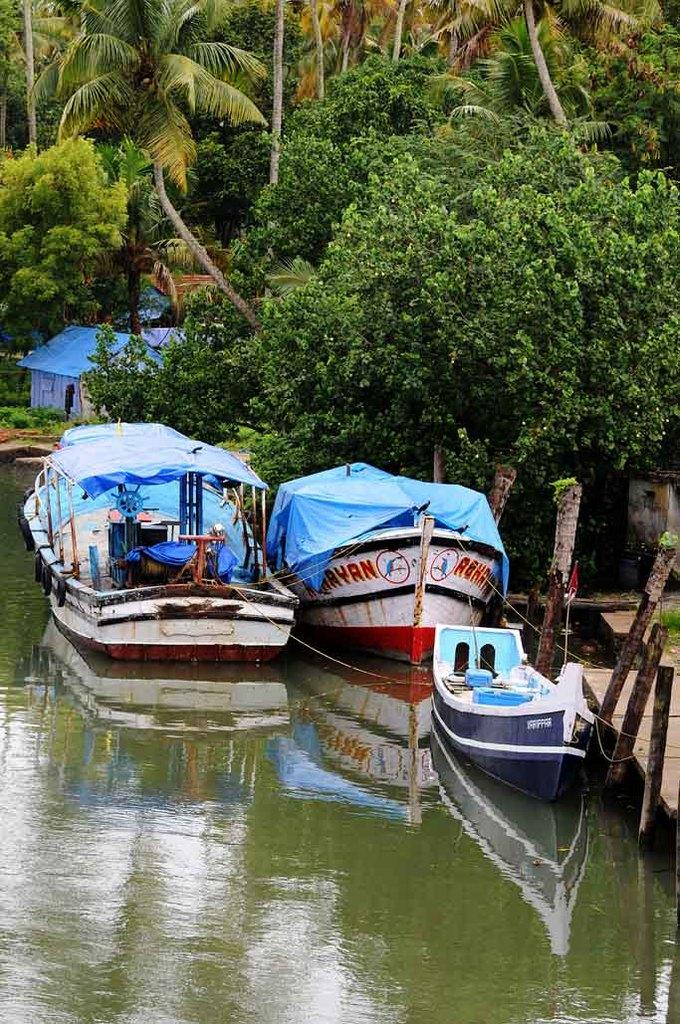What type of vehicles can be seen in the image? There are boats visible in the image. Can you describe the position of the boats in relation to the water? The boats are above the water. What can be seen in the background of the image? There are trees and a house in the background of the image. What type of canvas can be seen hanging on the boats in the image? There is no canvas visible on the boats in the image. Where might the friends be sitting while observing the boats in the image? The provided facts do not mention friends or a sofa, so it cannot be determined from the image. 